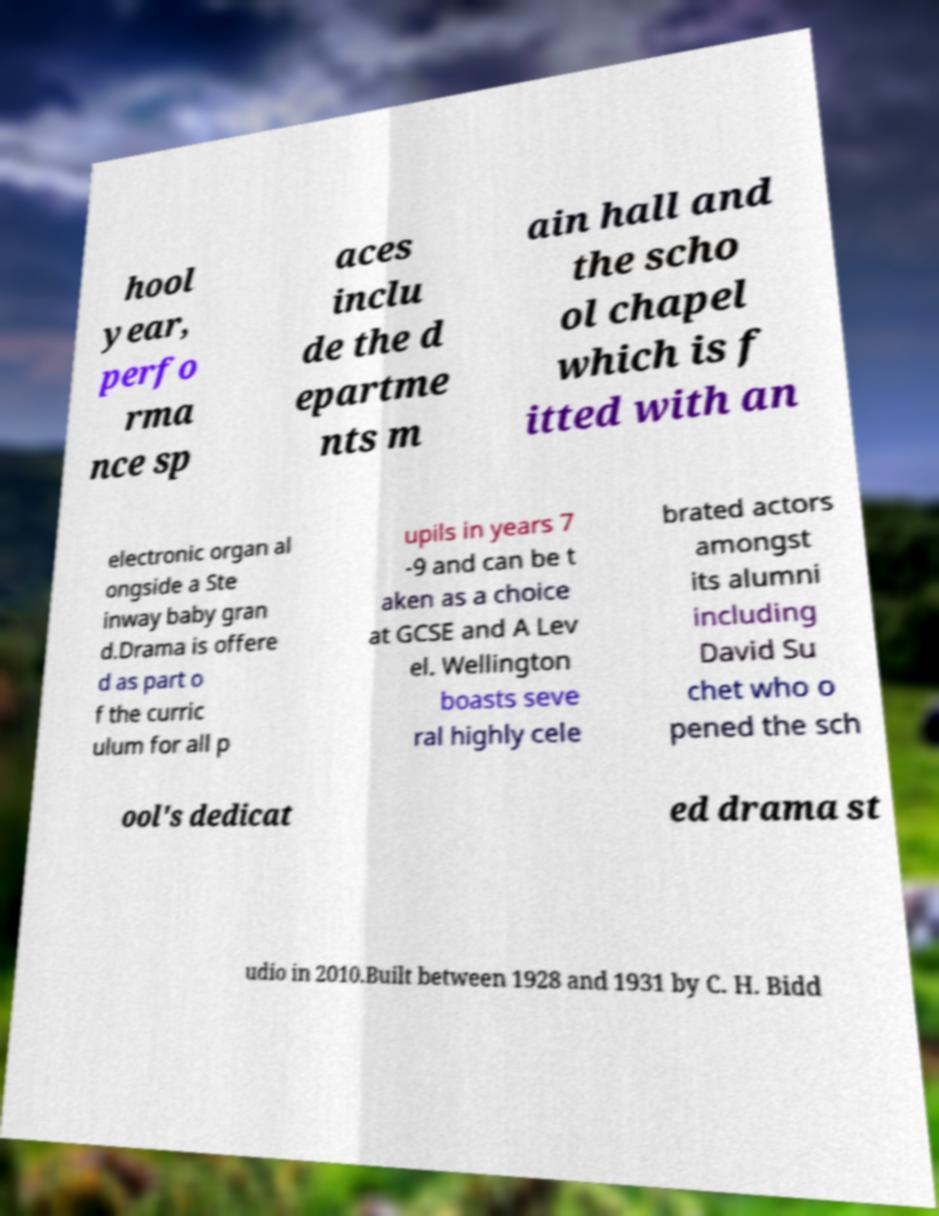Can you read and provide the text displayed in the image?This photo seems to have some interesting text. Can you extract and type it out for me? hool year, perfo rma nce sp aces inclu de the d epartme nts m ain hall and the scho ol chapel which is f itted with an electronic organ al ongside a Ste inway baby gran d.Drama is offere d as part o f the curric ulum for all p upils in years 7 -9 and can be t aken as a choice at GCSE and A Lev el. Wellington boasts seve ral highly cele brated actors amongst its alumni including David Su chet who o pened the sch ool's dedicat ed drama st udio in 2010.Built between 1928 and 1931 by C. H. Bidd 